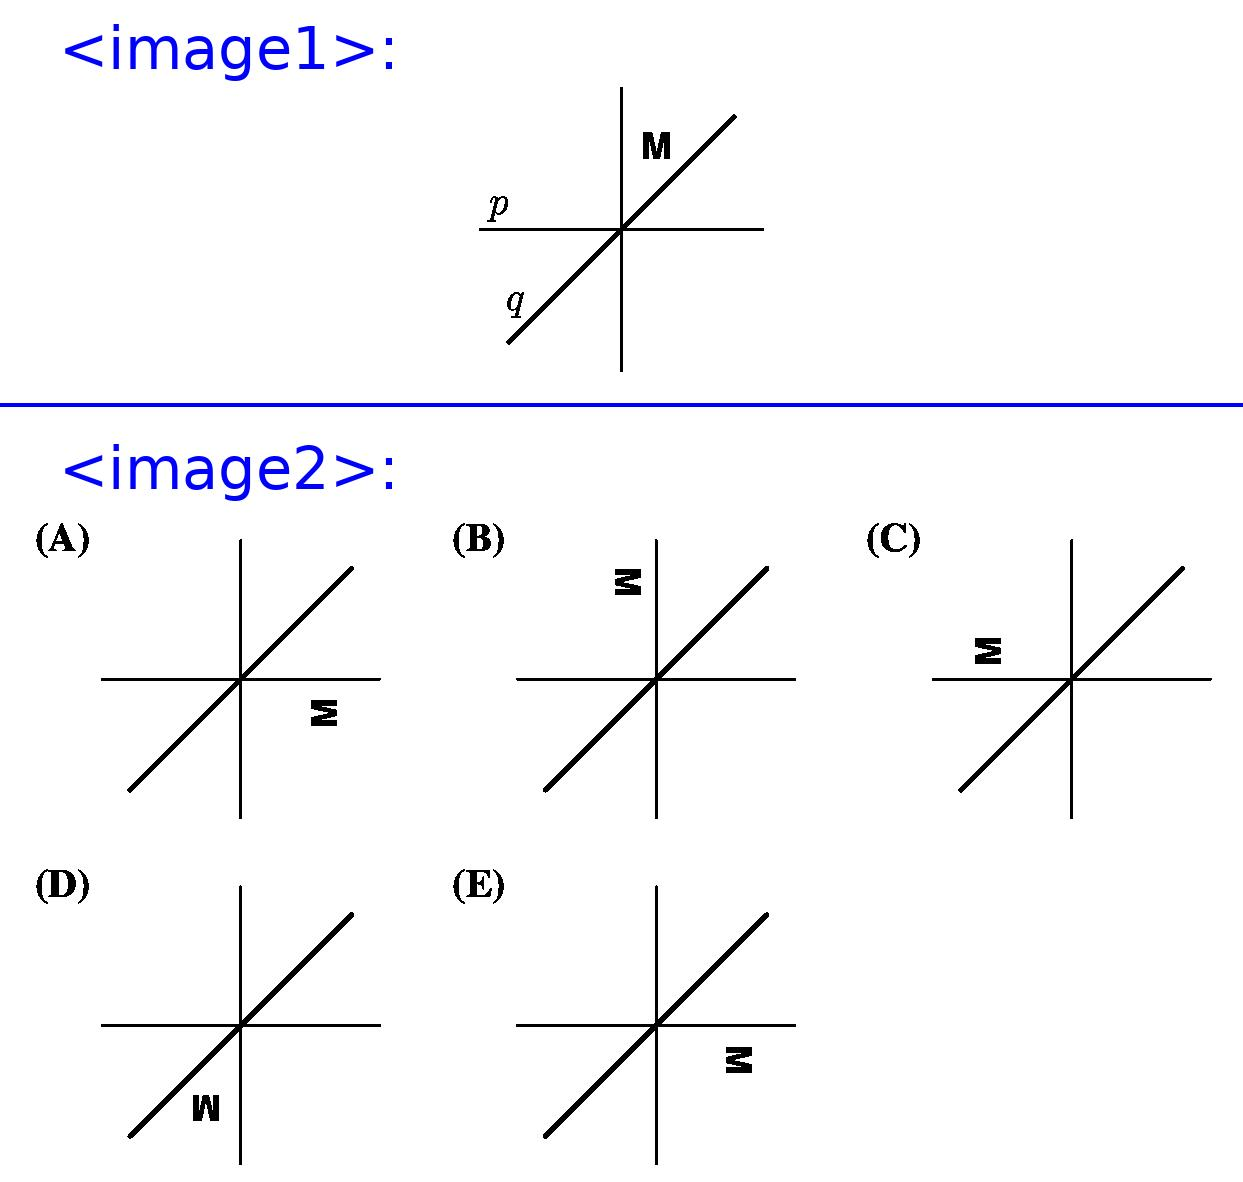Can you explain what reflection over a line means in geometry? Certainly! In geometry, reflection over a line, also known as a mirror reflection, means creating a mirror image of a shape, so that the line of reflection acts as a mirror. Every point of the original shape is flipped across the line to the opposite side, maintaining its distance from the line. The resulting image is a congruent figure where corresponding points are equidistant from the reflection line, but on opposite sides.  How can we verify the accuracy of the reflections performed on letter M? To verify the accuracy of reflections, you can use a ruler or a straightedge to ensure that points before and after the reflection are equidistant from the reflection line. Imagining or drawing perpendicular lines from points on letter 'M' to the reflection lines 'p' and 'q' and ensuring those distances remain constant before and after the reflection will help ascertain accuracy. You can also use tracing paper to flip the image manually if you're working with a physical copy. 